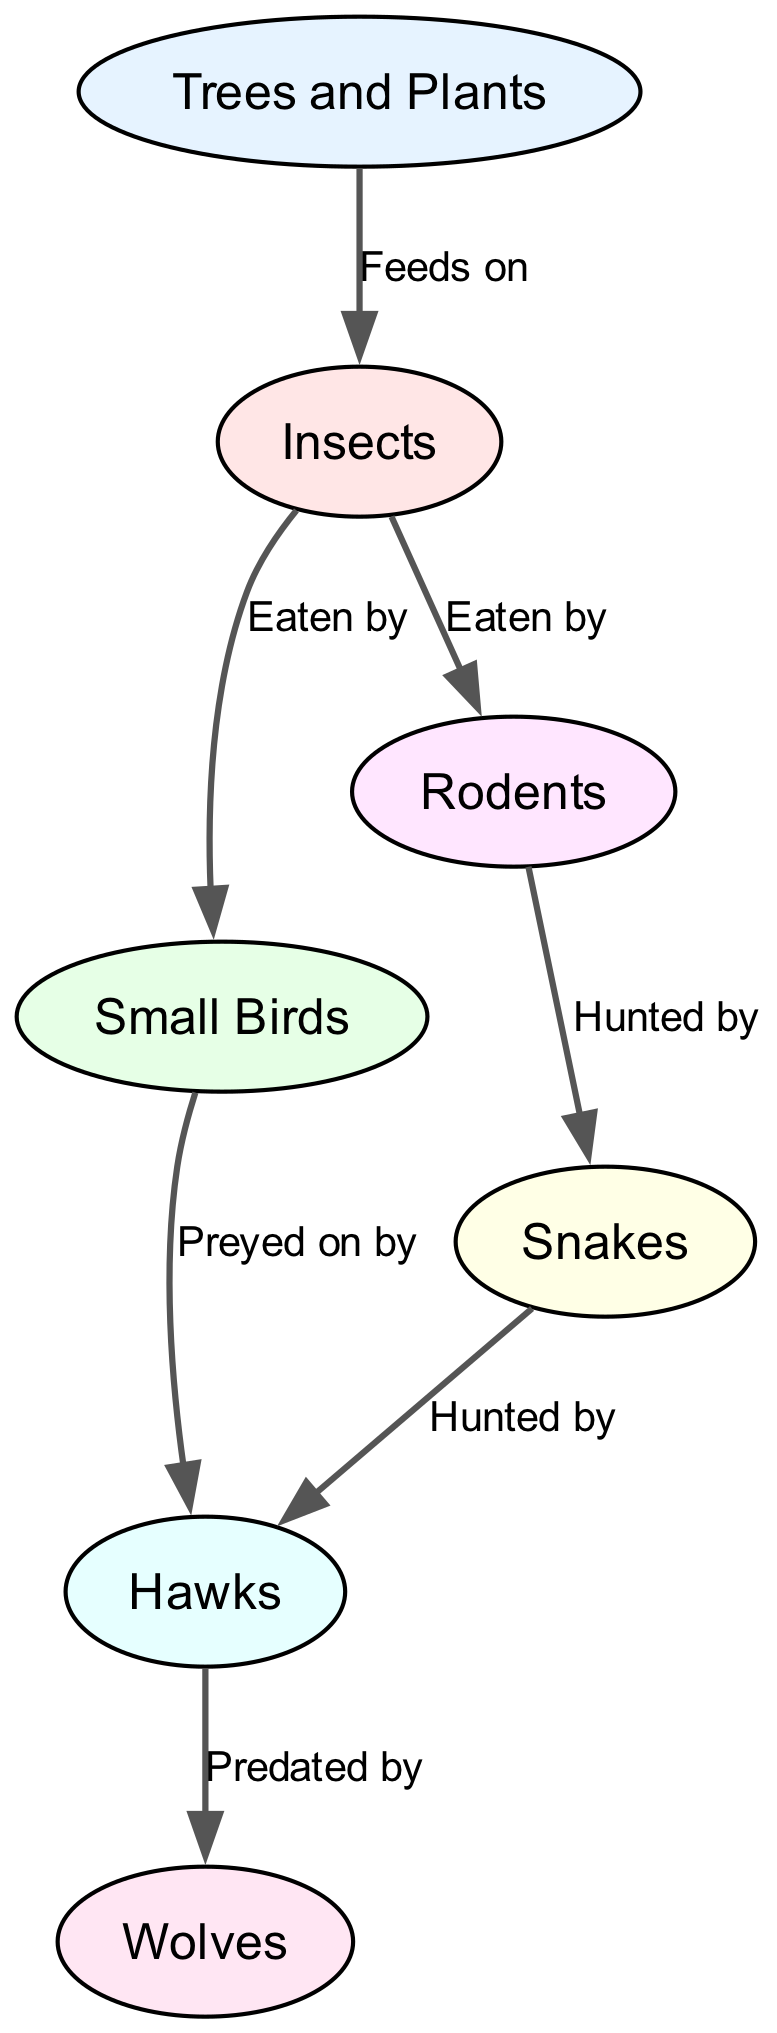What are the primary producers in this food chain? In the diagram, the primary producers are the first node labeled "Trees and Plants," which forms the base of the food chain by providing energy through photosynthesis for other organisms.
Answer: Trees and Plants How many levels are in the food chain? The diagram has distinct levels based on the flow of energy: Trees and Plants (producers), Insects (primary consumers), Small Birds and Rodents (secondary consumers), Snakes and Hawks (tertiary consumers), and Wolves (quaternary consumers). Counting these distinct levels reveals there are 5 levels in total.
Answer: 5 Which animal is predated by Hawks? According to the diagram, the Small Birds and Snakes are listed as prey for the Hawks. This means both types of animals are hunted by Hawks. The question asks for one specific instance, therefore either name could work.
Answer: Small Birds What type of relationship exists between Snakes and Hawks? The relationship shown in the diagram between Snakes and Hawks is one where Snakes are hunted by Hawks. This indicates that Hawks are the predators of Snakes, demonstrating a predator-prey dynamic.
Answer: Hunted by Are Rodents eaten by Insects? In the food chain, the diagram indicates that Insects do not directly eat Rodents; instead, Insects are shown to eat smaller organisms, leading to Rodents being consumed by a larger predator thereafter. Thus, the relationship does not exist as stated in the question.
Answer: No How many predators are in the food chain? To find the number of predators, we identify all nodes that have a corresponding edge indicating they hunt another animal. The edges indicate that Hawks hunt Snakes and Small Birds, and that Wolves are at the top. Therefore, there are a total of 3 predators identified here.
Answer: 3 What do Rodents feed on? Following the edges in the diagram, to determine what Rodents feed on we see that they are not mentioned as prey for another organism in this specific chain, implying that this detail is not defined in this food web. Thus, the diagram leads us to conclude Rodents are not explicitly shown as food for any other organims.
Answer: Not specified What is the relationship between Trees and Plants and Insects? The diagram clearly displays a direct feeding relationship wherein Insects are shown to be fed on Trees and Plants. This categorization signifies the importance of primary producers to support the lower levels in the food chain.
Answer: Feeds on 